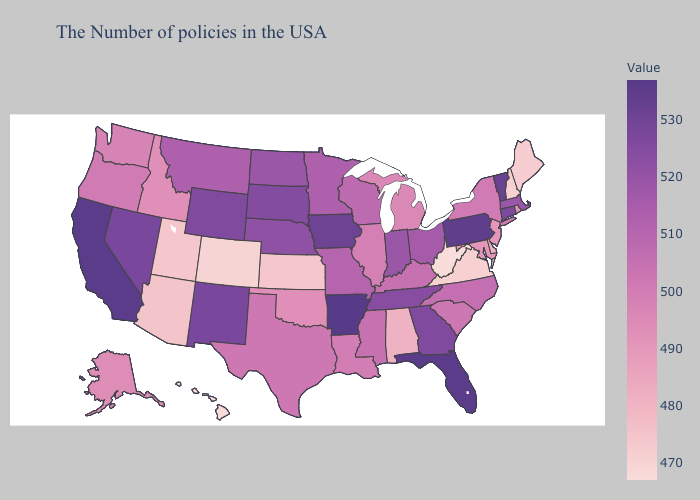Among the states that border Montana , which have the lowest value?
Keep it brief. Idaho. Does Arkansas have the highest value in the USA?
Write a very short answer. Yes. Does Idaho have the lowest value in the USA?
Keep it brief. No. Which states have the lowest value in the USA?
Short answer required. West Virginia, Hawaii. 